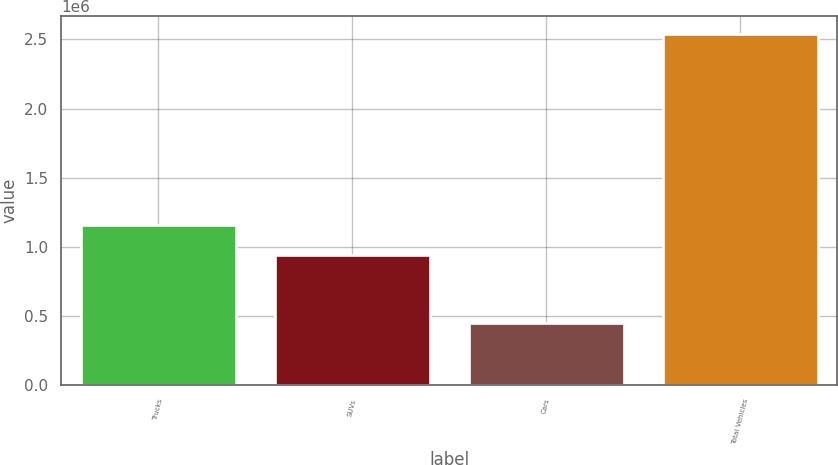Convert chart. <chart><loc_0><loc_0><loc_500><loc_500><bar_chart><fcel>Trucks<fcel>SUVs<fcel>Cars<fcel>Total Vehicles<nl><fcel>1.15602e+06<fcel>937845<fcel>445999<fcel>2.53987e+06<nl></chart> 